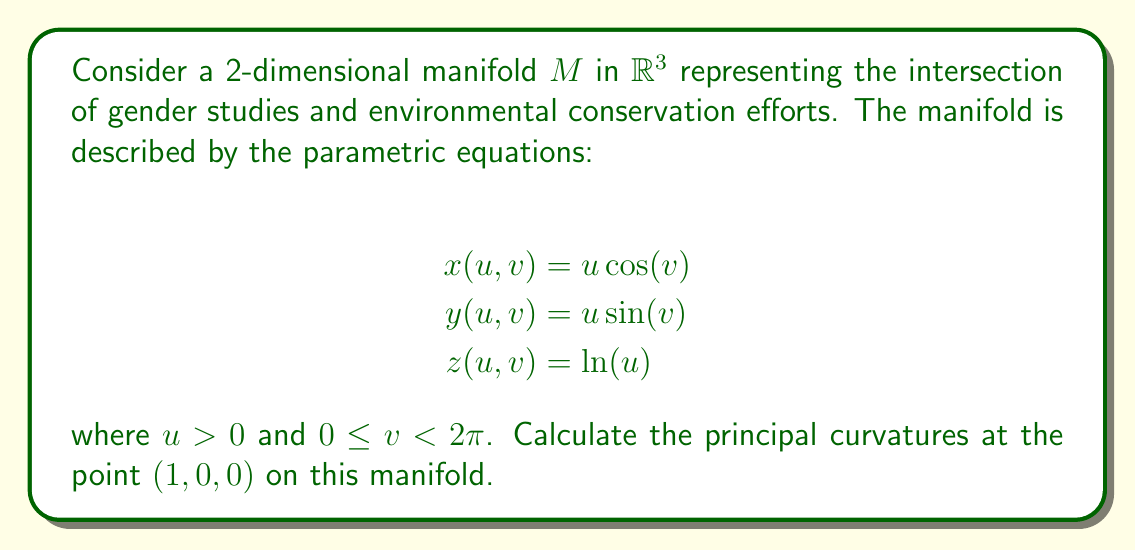Can you answer this question? To find the principal curvatures, we need to follow these steps:

1) First, calculate the first fundamental form coefficients:
   $$E = \left(\frac{\partial x}{\partial u}\right)^2 + \left(\frac{\partial y}{\partial u}\right)^2 + \left(\frac{\partial z}{\partial u}\right)^2$$
   $$F = \frac{\partial x}{\partial u}\frac{\partial x}{\partial v} + \frac{\partial y}{\partial u}\frac{\partial y}{\partial v} + \frac{\partial z}{\partial u}\frac{\partial z}{\partial v}$$
   $$G = \left(\frac{\partial x}{\partial v}\right)^2 + \left(\frac{\partial y}{\partial v}\right)^2 + \left(\frac{\partial z}{\partial v}\right)^2$$

2) Calculate the second fundamental form coefficients:
   $$e = \frac{\mathbf{N} \cdot \frac{\partial^2\mathbf{r}}{\partial u^2}}{\|\mathbf{N}\|}$$
   $$f = \frac{\mathbf{N} \cdot \frac{\partial^2\mathbf{r}}{\partial u\partial v}}{\|\mathbf{N}\|}$$
   $$g = \frac{\mathbf{N} \cdot \frac{\partial^2\mathbf{r}}{\partial v^2}}{\|\mathbf{N}\|}$$

   where $\mathbf{N}$ is the normal vector to the surface.

3) Compute the partial derivatives:
   $$\frac{\partial x}{\partial u} = \cos(v), \frac{\partial x}{\partial v} = -u\sin(v)$$
   $$\frac{\partial y}{\partial u} = \sin(v), \frac{\partial y}{\partial v} = u\cos(v)$$
   $$\frac{\partial z}{\partial u} = \frac{1}{u}, \frac{\partial z}{\partial v} = 0$$

4) Calculate E, F, and G at $(1, 0, 0)$:
   $$E = \cos^2(0) + \sin^2(0) + 1^2 = 2$$
   $$F = \cos(0)(-\sin(0)) + \sin(0)\cos(0) + 0 = 0$$
   $$G = (-\sin(0))^2 + \cos^2(0) + 0^2 = 1$$

5) Calculate the normal vector $\mathbf{N}$:
   $$\mathbf{N} = \frac{\partial\mathbf{r}}{\partial u} \times \frac{\partial\mathbf{r}}{\partial v} = (-\sin(v), \cos(v), -1)$$
   At $(1, 0, 0)$, $\mathbf{N} = (0, 1, -1)$

6) Calculate e, f, and g at $(1, 0, 0)$:
   $$e = \frac{(0, 1, -1) \cdot (0, 0, -1)}{\sqrt{2}} = \frac{1}{\sqrt{2}}$$
   $$f = \frac{(0, 1, -1) \cdot (-1, 0, 0)}{\sqrt{2}} = 0$$
   $$g = \frac{(0, 1, -1) \cdot (-1, 0, 0)}{\sqrt{2}} = 0$$

7) The principal curvatures are the eigenvalues of the shape operator. They can be found by solving:
   $$\det\begin{pmatrix}
   e-\kappa E & f-\kappa F\\
   f-\kappa F & g-\kappa G
   \end{pmatrix} = 0$$

   Substituting the values:
   $$\det\begin{pmatrix}
   \frac{1}{\sqrt{2}}-2\kappa & 0\\
   0 & -\kappa
   \end{pmatrix} = 0$$

8) Solving this equation:
   $$(\frac{1}{\sqrt{2}}-2\kappa)(-\kappa) = 0$$

   We get:
   $$\kappa_1 = \frac{1}{2\sqrt{2}}, \kappa_2 = 0$$

Therefore, the principal curvatures at $(1, 0, 0)$ are $\frac{1}{2\sqrt{2}}$ and $0$.
Answer: $\kappa_1 = \frac{1}{2\sqrt{2}}, \kappa_2 = 0$ 